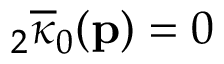Convert formula to latex. <formula><loc_0><loc_0><loc_500><loc_500>{ } _ { 2 } \overline { \kappa } _ { 0 } ( p ) = 0</formula> 